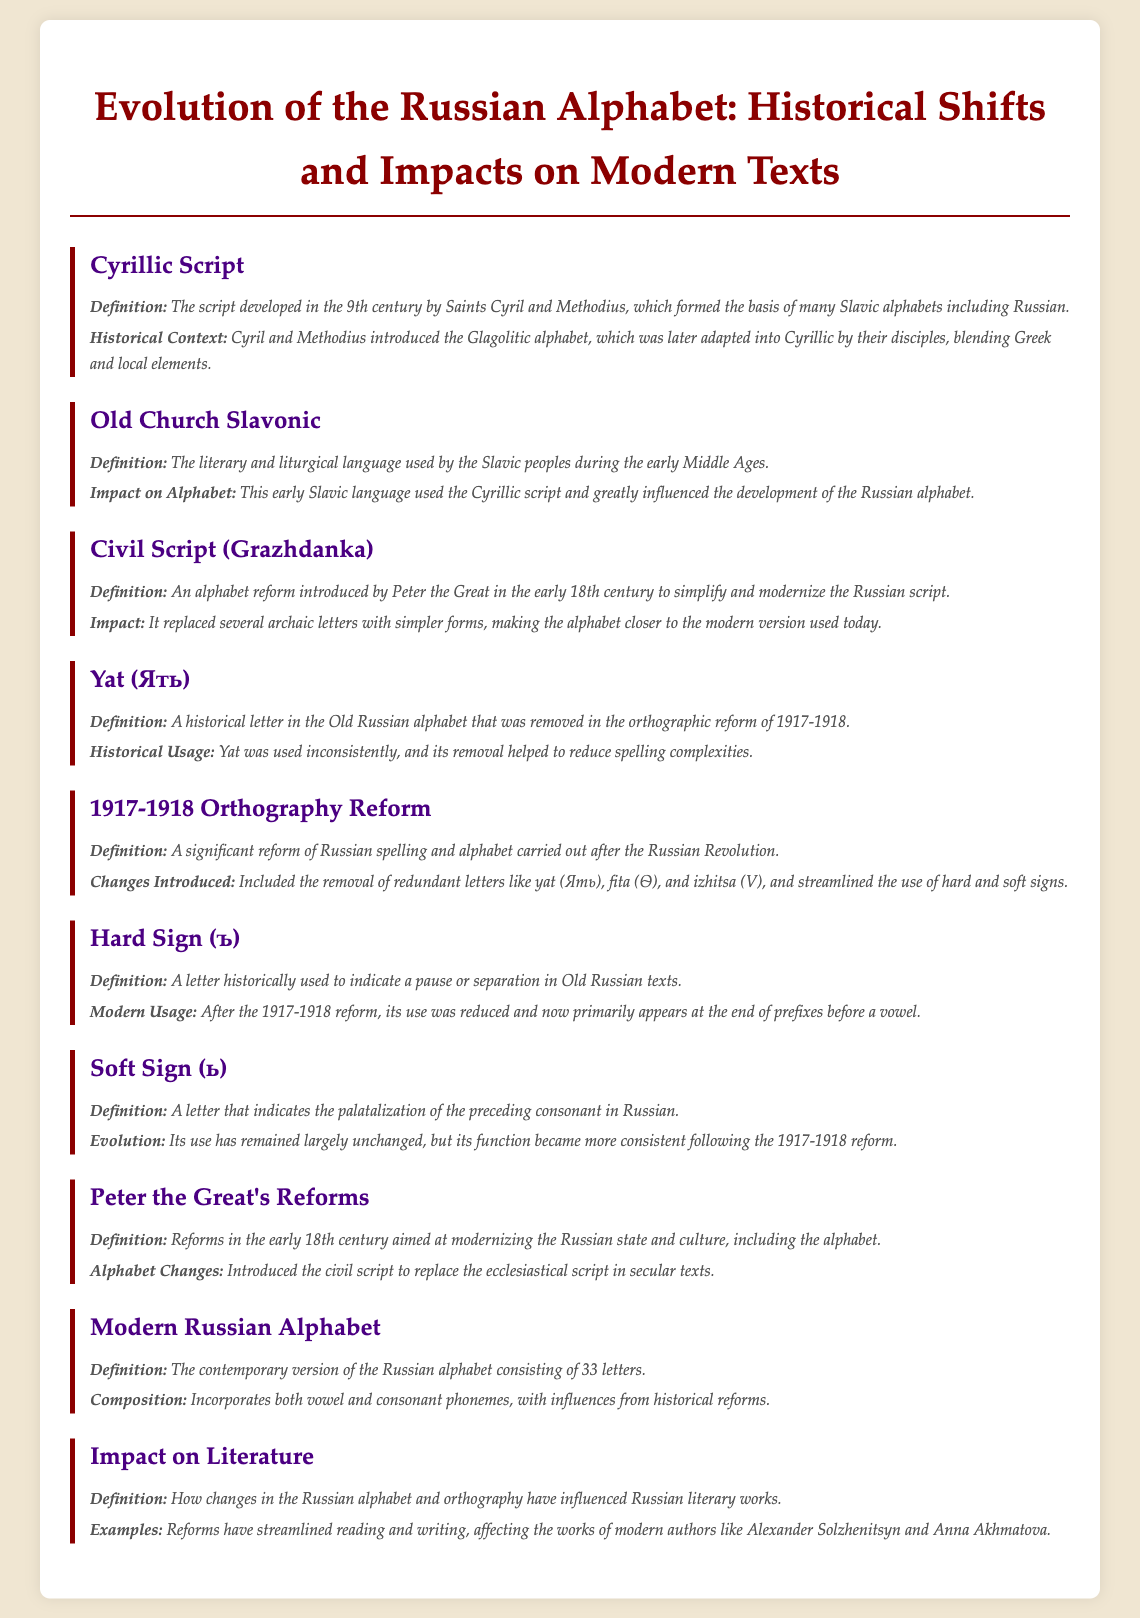What is the script developed in the 9th century? The document states that the Cyrillic Script was developed in the 9th century by Saints Cyril and Methodius.
Answer: Cyrillic Script What is the literary language used by Slavic peoples in early Middle Ages? The document defines Old Church Slavonic as the literary and liturgical language used by the Slavic peoples during the early Middle Ages.
Answer: Old Church Slavonic What reform did Peter the Great introduce in the early 18th century? The document indicates that Peter the Great introduced the Civil Script to simplify and modernize the Russian script.
Answer: Civil Script (Grazhdanka) Which letter was removed during the orthographic reform of 1917-1918? The document specifies that the Yat (Ять) was a historical letter removed during the orthographic reform of 1917-1918.
Answer: Yat (Ять) How many letters are in the modern Russian alphabet? According to the document, the modern Russian alphabet consists of 33 letters.
Answer: 33 What impact did the 1917-1918 reform have on the usage of the Hard Sign? The document states that after the 1917-1918 reform, the use of the Hard Sign was reduced and is now mostly at the end of prefixes before a vowel.
Answer: Reduced What was the main goal of Peter the Great's reforms concerning the alphabet? The document mentions that Peter the Great's reforms aimed to modernize the Russian state and culture, including the alphabet.
Answer: Modernization What type of texts did the Civil Script replace? The document indicates that the Civil Script was introduced to replace the ecclesiastical script in secular texts.
Answer: Ecclesiastical script How have the reforms affected modern authors? The document exemplifies that changes in the Russian alphabet and orthography have streamlined reading and writing, impacting authors like Alexander Solzhenitsyn and Anna Akhmatova.
Answer: Streamlined reading and writing 